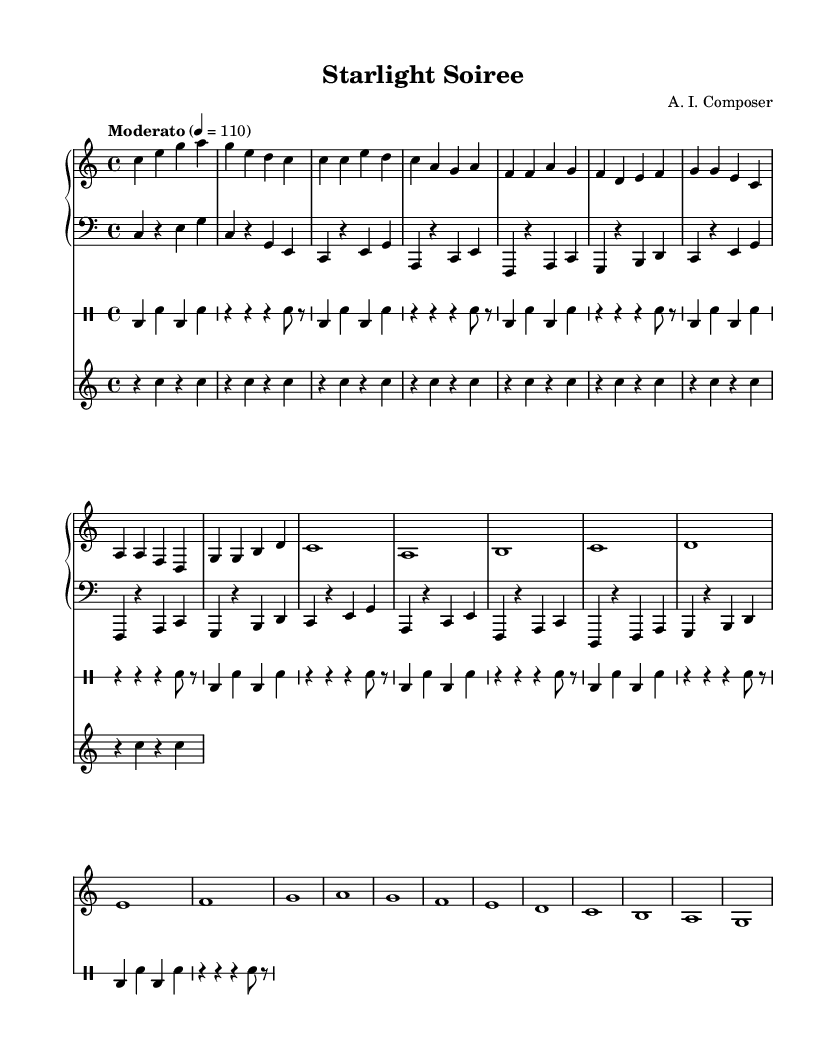What is the key signature of this music? The key signature is C major, which has no sharps or flats.
Answer: C major What is the time signature of this music? The time signature is indicated at the beginning of the piece, and it shows 4 beats per measure, which is typical for dance music.
Answer: 4/4 What is the tempo marking of the music? The tempo marking at the start indicates a moderately fast pace of 110 beats per minute, making it suitable for a dance environment.
Answer: Moderato, 110 How many sections can you identify in this piece? By analyzing the structure, we can distinguish four main sections: Intro, Verse, Chorus, and Bridge, which are typical in dance music formats.
Answer: Four What rhythmic pattern is predominant in the drum part? The drum part follows a simple kick-snare rhythm, creating a steady dance beat suitable for a lounge-style atmosphere, specifically alternating bass drum and snare hits.
Answer: Kick-snare What instruments are involved in this piece? By examining the score, the instruments included are piano, bass, drums, and vibraphone, each contributing to the lounge-style arrangement.
Answer: Piano, bass, drums, vibraphone What is the highest pitch note in the piece? The highest pitch is noted in the piano part during the sections, with 'g' being the highest in the initial parts, which is a common characteristic for leading melodies in dance music.
Answer: G 